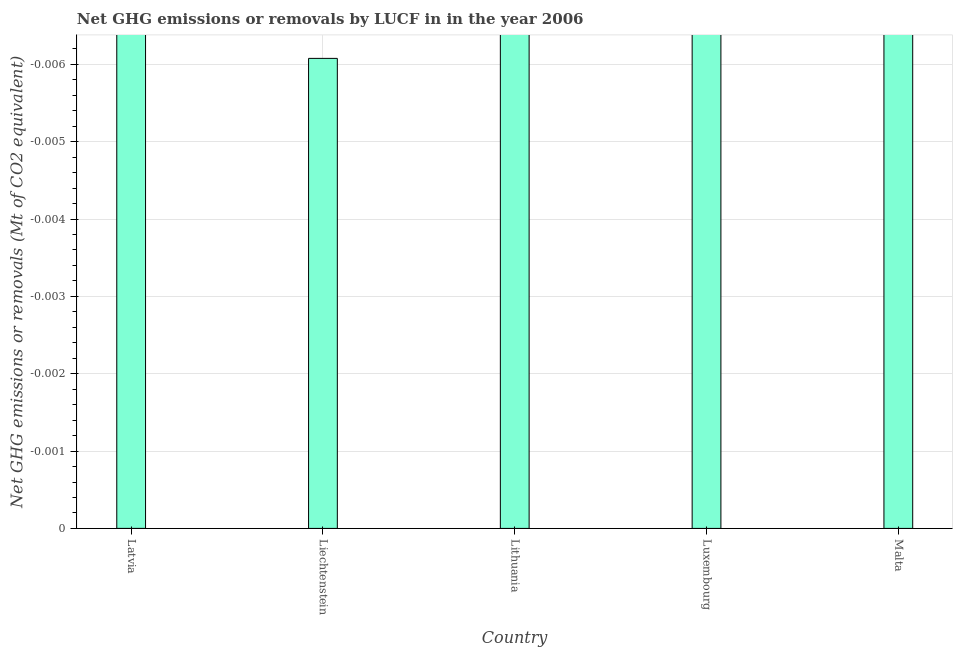Does the graph contain any zero values?
Keep it short and to the point. Yes. Does the graph contain grids?
Give a very brief answer. Yes. What is the title of the graph?
Keep it short and to the point. Net GHG emissions or removals by LUCF in in the year 2006. What is the label or title of the Y-axis?
Ensure brevity in your answer.  Net GHG emissions or removals (Mt of CO2 equivalent). Across all countries, what is the minimum ghg net emissions or removals?
Your answer should be very brief. 0. What is the sum of the ghg net emissions or removals?
Offer a very short reply. 0. What is the median ghg net emissions or removals?
Give a very brief answer. 0. In how many countries, is the ghg net emissions or removals greater than the average ghg net emissions or removals taken over all countries?
Your answer should be compact. 0. How many bars are there?
Offer a terse response. 0. What is the difference between two consecutive major ticks on the Y-axis?
Your response must be concise. 0. Are the values on the major ticks of Y-axis written in scientific E-notation?
Your response must be concise. No. What is the Net GHG emissions or removals (Mt of CO2 equivalent) of Latvia?
Offer a very short reply. 0. What is the Net GHG emissions or removals (Mt of CO2 equivalent) of Luxembourg?
Give a very brief answer. 0. 